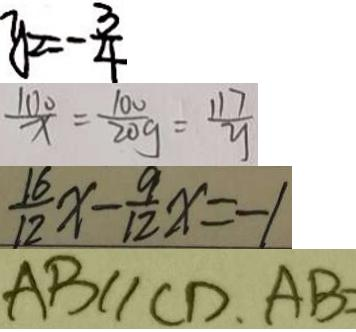<formula> <loc_0><loc_0><loc_500><loc_500>y _ { 2 } = - \frac { 3 } { 4 } 
 \frac { 1 0 0 } { x } = \frac { 1 0 0 } { 2 0 g } = \frac { 1 1 7 } { y } 
 \frac { 1 6 } { 1 2 } x - \frac { 9 } { 1 2 } x = - 1 
 A B / / C D , A B =</formula> 